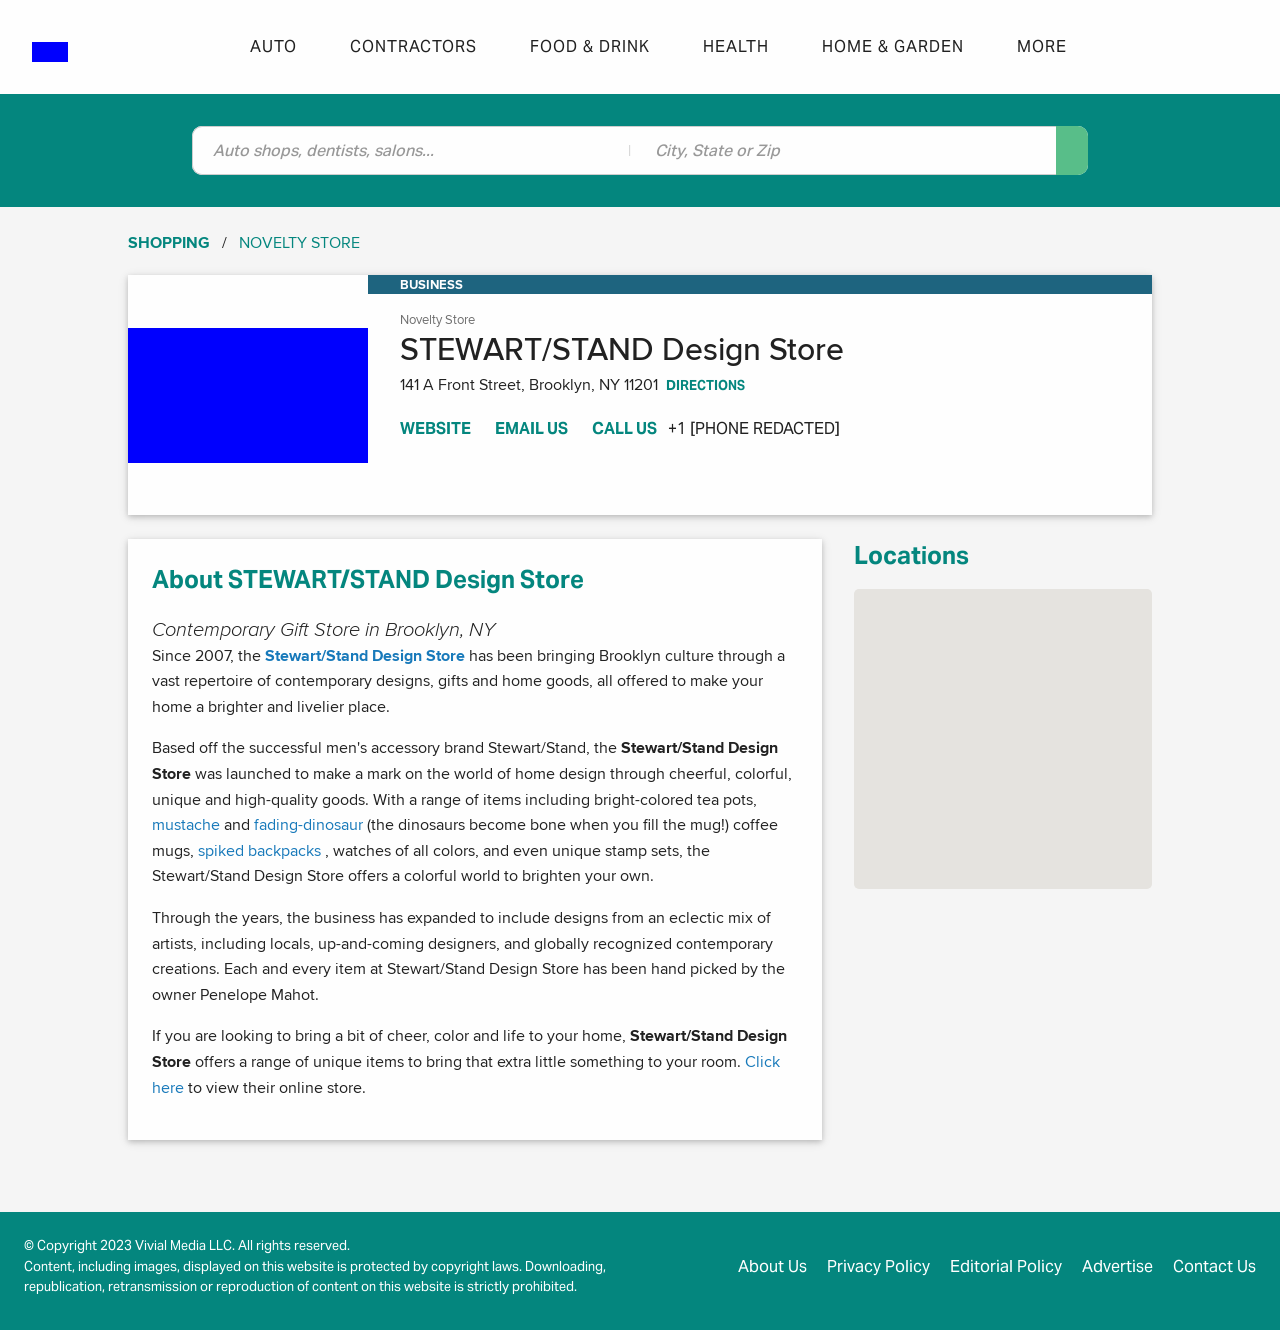Can you tell me more about some unique products that are available at the STEWART/STAND Design Store? Certainly! STEWART/STAND Design Store offers a variety of unique products that include brightly-colored tea pots, mugs with color-changing dinosaur designs, and innovative spiked backpacks. Each product is chosen for its high-quality and distinctive design, making them perfect gifts or additions to any home. What makes these products stand out in terms of design? These products stand out due to their creative and often whimsical designs. For instance, the color-changing mugs change appearance when hot liquid is added, revealing dinosaur bones, adding an element of surprise and delight. The spiked backpacks offer a bold and edgy look while maintaining functionality, showcasing a fusion of art and utility. 